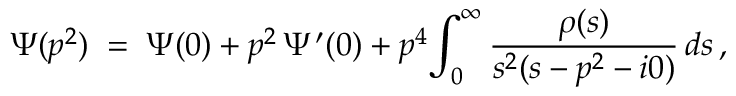<formula> <loc_0><loc_0><loc_500><loc_500>\Psi ( p ^ { 2 } ) \, = \, \Psi ( 0 ) + p ^ { 2 } \, \Psi ^ { \prime } ( 0 ) + p ^ { 4 } \, \int _ { 0 } ^ { \infty } \frac { \rho ( s ) } { s ^ { 2 } ( s - p ^ { 2 } - i 0 ) } \, d s \, ,</formula> 